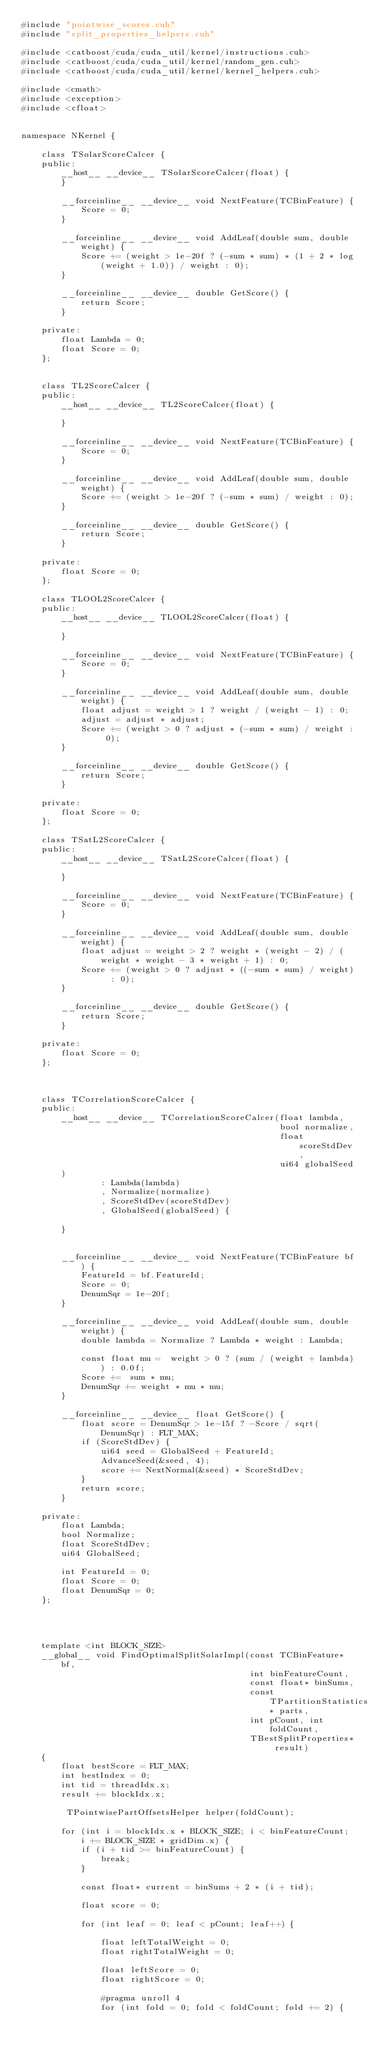Convert code to text. <code><loc_0><loc_0><loc_500><loc_500><_Cuda_>#include "pointwise_scores.cuh"
#include "split_properties_helpers.cuh"

#include <catboost/cuda/cuda_util/kernel/instructions.cuh>
#include <catboost/cuda/cuda_util/kernel/random_gen.cuh>
#include <catboost/cuda/cuda_util/kernel/kernel_helpers.cuh>

#include <cmath>
#include <exception>
#include <cfloat>


namespace NKernel {

    class TSolarScoreCalcer {
    public:
        __host__ __device__ TSolarScoreCalcer(float) {
        }

        __forceinline__ __device__ void NextFeature(TCBinFeature) {
            Score = 0;
        }

        __forceinline__ __device__ void AddLeaf(double sum, double weight) {
            Score += (weight > 1e-20f ? (-sum * sum) * (1 + 2 * log(weight + 1.0)) / weight : 0);
        }

        __forceinline__ __device__ double GetScore() {
            return Score;
        }

    private:
        float Lambda = 0;
        float Score = 0;
    };


    class TL2ScoreCalcer {
    public:
        __host__ __device__ TL2ScoreCalcer(float) {

        }

        __forceinline__ __device__ void NextFeature(TCBinFeature) {
            Score = 0;
        }

        __forceinline__ __device__ void AddLeaf(double sum, double weight) {
            Score += (weight > 1e-20f ? (-sum * sum) / weight : 0);
        }

        __forceinline__ __device__ double GetScore() {
            return Score;
        }

    private:
        float Score = 0;
    };

    class TLOOL2ScoreCalcer {
    public:
        __host__ __device__ TLOOL2ScoreCalcer(float) {

        }

        __forceinline__ __device__ void NextFeature(TCBinFeature) {
            Score = 0;
        }

        __forceinline__ __device__ void AddLeaf(double sum, double weight) {
            float adjust = weight > 1 ? weight / (weight - 1) : 0;
            adjust = adjust * adjust;
            Score += (weight > 0 ? adjust * (-sum * sum) / weight : 0);
        }

        __forceinline__ __device__ double GetScore() {
            return Score;
        }

    private:
        float Score = 0;
    };

    class TSatL2ScoreCalcer {
    public:
        __host__ __device__ TSatL2ScoreCalcer(float) {

        }

        __forceinline__ __device__ void NextFeature(TCBinFeature) {
            Score = 0;
        }

        __forceinline__ __device__ void AddLeaf(double sum, double weight) {
            float adjust = weight > 2 ? weight * (weight - 2) / (weight * weight - 3 * weight + 1) : 0;
            Score += (weight > 0 ? adjust * ((-sum * sum) / weight)  : 0);
        }

        __forceinline__ __device__ double GetScore() {
            return Score;
        }

    private:
        float Score = 0;
    };



    class TCorrelationScoreCalcer {
    public:
        __host__ __device__ TCorrelationScoreCalcer(float lambda,
                                                    bool normalize,
                                                    float scoreStdDev,
                                                    ui64 globalSeed
        )
                : Lambda(lambda)
                , Normalize(normalize)
                , ScoreStdDev(scoreStdDev)
                , GlobalSeed(globalSeed) {

        }


        __forceinline__ __device__ void NextFeature(TCBinFeature bf) {
            FeatureId = bf.FeatureId;
            Score = 0;
            DenumSqr = 1e-20f;
        }

        __forceinline__ __device__ void AddLeaf(double sum, double weight) {
            double lambda = Normalize ? Lambda * weight : Lambda;

            const float mu =  weight > 0 ? (sum / (weight + lambda)) : 0.0f;
            Score +=  sum * mu;
            DenumSqr += weight * mu * mu;
        }

        __forceinline__ __device__ float GetScore() {
            float score = DenumSqr > 1e-15f ? -Score / sqrt(DenumSqr) : FLT_MAX;
            if (ScoreStdDev) {
                ui64 seed = GlobalSeed + FeatureId;
                AdvanceSeed(&seed, 4);
                score += NextNormal(&seed) * ScoreStdDev;
            }
            return score;
        }

    private:
        float Lambda;
        bool Normalize;
        float ScoreStdDev;
        ui64 GlobalSeed;

        int FeatureId = 0;
        float Score = 0;
        float DenumSqr = 0;
    };




    template <int BLOCK_SIZE>
    __global__ void FindOptimalSplitSolarImpl(const TCBinFeature* bf,
                                              int binFeatureCount,
                                              const float* binSums,
                                              const TPartitionStatistics* parts,
                                              int pCount, int foldCount,
                                              TBestSplitProperties* result)
    {
        float bestScore = FLT_MAX;
        int bestIndex = 0;
        int tid = threadIdx.x;
        result += blockIdx.x;

         TPointwisePartOffsetsHelper helper(foldCount);

        for (int i = blockIdx.x * BLOCK_SIZE; i < binFeatureCount; i += BLOCK_SIZE * gridDim.x) {
            if (i + tid >= binFeatureCount) {
                break;
            }

            const float* current = binSums + 2 * (i + tid);

            float score = 0;

            for (int leaf = 0; leaf < pCount; leaf++) {

                float leftTotalWeight = 0;
                float rightTotalWeight = 0;

                float leftScore = 0;
                float rightScore = 0;

                #pragma unroll 4
                for (int fold = 0; fold < foldCount; fold += 2) {
</code> 